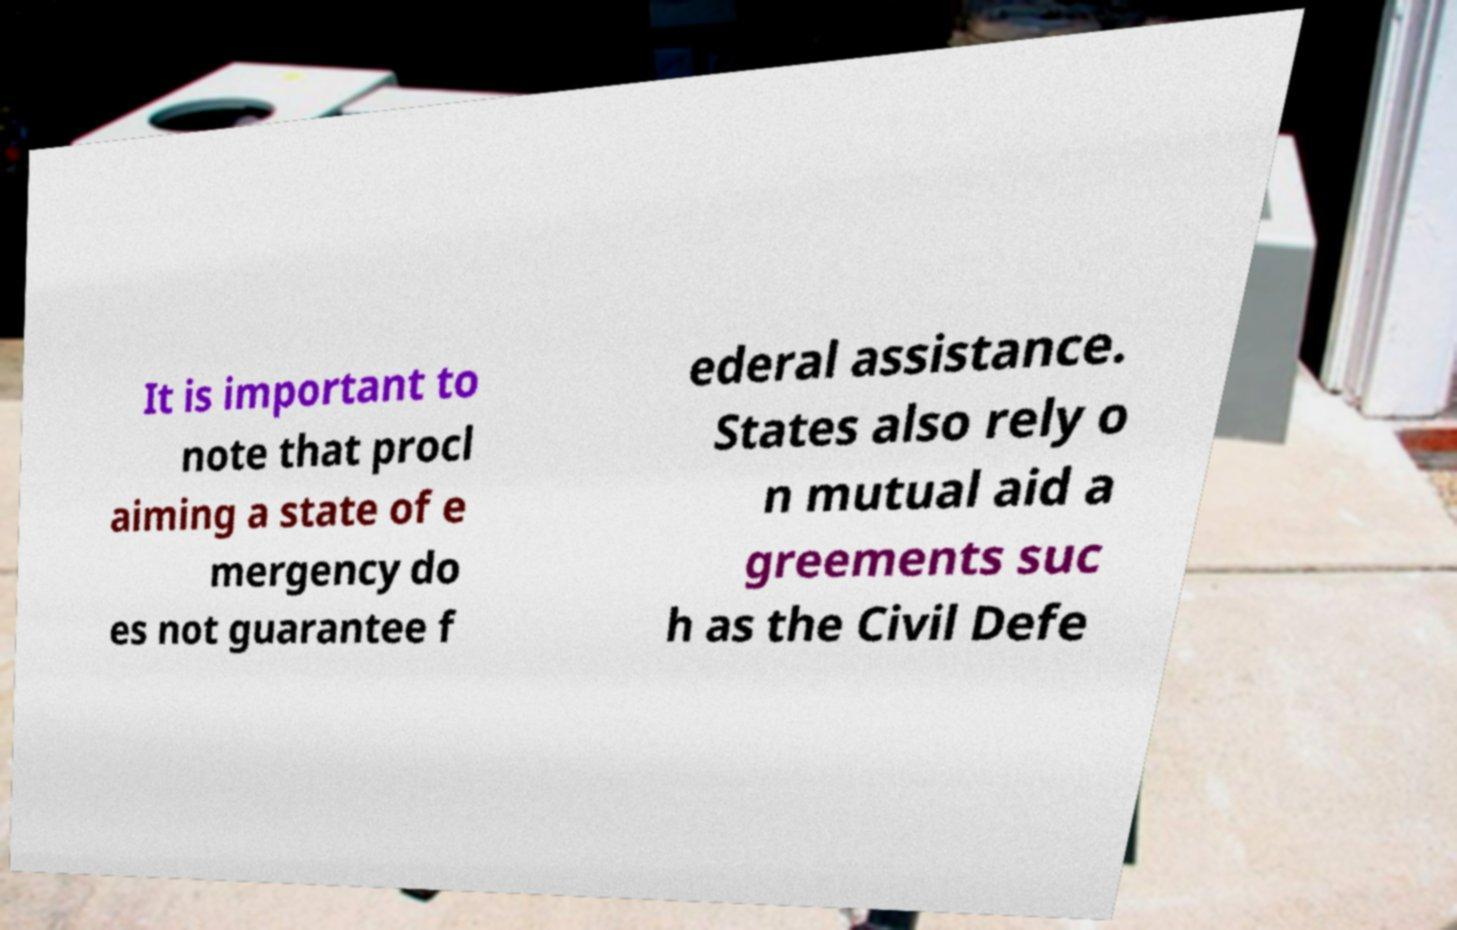What messages or text are displayed in this image? I need them in a readable, typed format. It is important to note that procl aiming a state of e mergency do es not guarantee f ederal assistance. States also rely o n mutual aid a greements suc h as the Civil Defe 